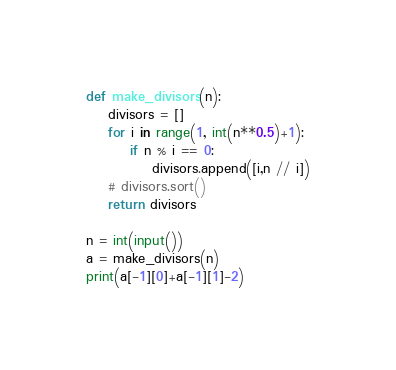Convert code to text. <code><loc_0><loc_0><loc_500><loc_500><_Python_>def make_divisors(n):
    divisors = []
    for i in range(1, int(n**0.5)+1):
        if n % i == 0:
            divisors.append([i,n // i])
    # divisors.sort()
    return divisors

n = int(input())
a = make_divisors(n)
print(a[-1][0]+a[-1][1]-2)</code> 